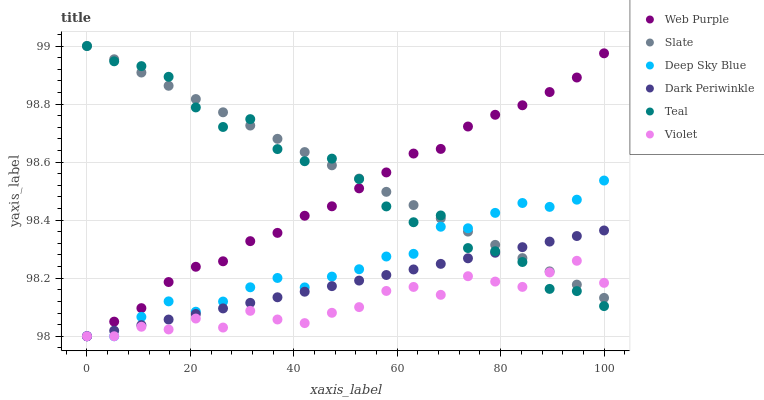Does Violet have the minimum area under the curve?
Answer yes or no. Yes. Does Slate have the maximum area under the curve?
Answer yes or no. Yes. Does Web Purple have the minimum area under the curve?
Answer yes or no. No. Does Web Purple have the maximum area under the curve?
Answer yes or no. No. Is Dark Periwinkle the smoothest?
Answer yes or no. Yes. Is Teal the roughest?
Answer yes or no. Yes. Is Slate the smoothest?
Answer yes or no. No. Is Slate the roughest?
Answer yes or no. No. Does Deep Sky Blue have the lowest value?
Answer yes or no. Yes. Does Slate have the lowest value?
Answer yes or no. No. Does Teal have the highest value?
Answer yes or no. Yes. Does Web Purple have the highest value?
Answer yes or no. No. Does Teal intersect Deep Sky Blue?
Answer yes or no. Yes. Is Teal less than Deep Sky Blue?
Answer yes or no. No. Is Teal greater than Deep Sky Blue?
Answer yes or no. No. 